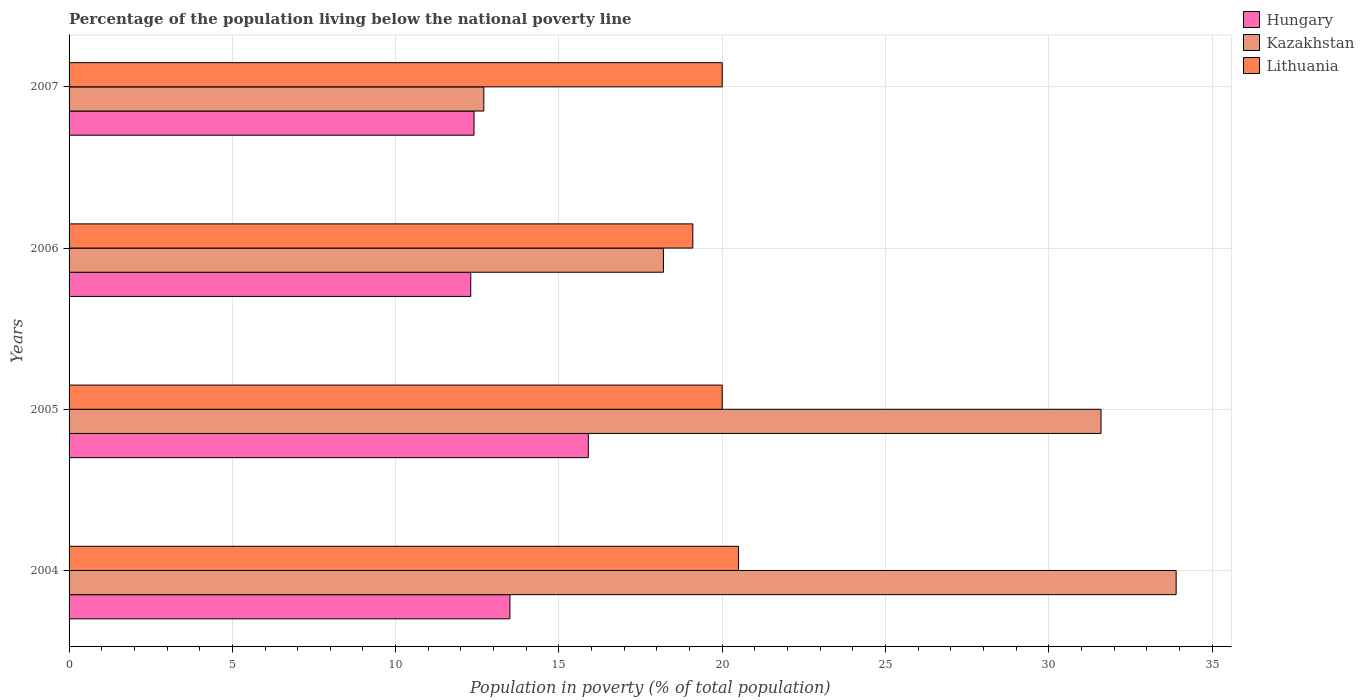How many bars are there on the 2nd tick from the top?
Offer a very short reply. 3. How many bars are there on the 1st tick from the bottom?
Give a very brief answer. 3. What is the label of the 1st group of bars from the top?
Your answer should be compact. 2007. In how many cases, is the number of bars for a given year not equal to the number of legend labels?
Offer a terse response. 0. Across all years, what is the maximum percentage of the population living below the national poverty line in Kazakhstan?
Provide a short and direct response. 33.9. Across all years, what is the minimum percentage of the population living below the national poverty line in Kazakhstan?
Ensure brevity in your answer.  12.7. In which year was the percentage of the population living below the national poverty line in Hungary maximum?
Keep it short and to the point. 2005. What is the total percentage of the population living below the national poverty line in Lithuania in the graph?
Make the answer very short. 79.6. What is the difference between the percentage of the population living below the national poverty line in Kazakhstan in 2005 and that in 2007?
Provide a succinct answer. 18.9. What is the difference between the percentage of the population living below the national poverty line in Hungary in 2004 and the percentage of the population living below the national poverty line in Lithuania in 2007?
Make the answer very short. -6.5. What is the average percentage of the population living below the national poverty line in Hungary per year?
Make the answer very short. 13.53. In the year 2005, what is the difference between the percentage of the population living below the national poverty line in Kazakhstan and percentage of the population living below the national poverty line in Lithuania?
Offer a terse response. 11.6. What is the ratio of the percentage of the population living below the national poverty line in Kazakhstan in 2005 to that in 2006?
Provide a succinct answer. 1.74. Is the difference between the percentage of the population living below the national poverty line in Kazakhstan in 2005 and 2006 greater than the difference between the percentage of the population living below the national poverty line in Lithuania in 2005 and 2006?
Keep it short and to the point. Yes. What is the difference between the highest and the second highest percentage of the population living below the national poverty line in Kazakhstan?
Ensure brevity in your answer.  2.3. What is the difference between the highest and the lowest percentage of the population living below the national poverty line in Lithuania?
Keep it short and to the point. 1.4. What does the 1st bar from the top in 2005 represents?
Keep it short and to the point. Lithuania. What does the 2nd bar from the bottom in 2006 represents?
Keep it short and to the point. Kazakhstan. Is it the case that in every year, the sum of the percentage of the population living below the national poverty line in Hungary and percentage of the population living below the national poverty line in Lithuania is greater than the percentage of the population living below the national poverty line in Kazakhstan?
Offer a terse response. Yes. How many bars are there?
Make the answer very short. 12. Are all the bars in the graph horizontal?
Offer a very short reply. Yes. Are the values on the major ticks of X-axis written in scientific E-notation?
Provide a succinct answer. No. Does the graph contain any zero values?
Ensure brevity in your answer.  No. Does the graph contain grids?
Make the answer very short. Yes. Where does the legend appear in the graph?
Make the answer very short. Top right. What is the title of the graph?
Provide a succinct answer. Percentage of the population living below the national poverty line. What is the label or title of the X-axis?
Ensure brevity in your answer.  Population in poverty (% of total population). What is the Population in poverty (% of total population) in Hungary in 2004?
Offer a terse response. 13.5. What is the Population in poverty (% of total population) in Kazakhstan in 2004?
Keep it short and to the point. 33.9. What is the Population in poverty (% of total population) in Lithuania in 2004?
Your answer should be compact. 20.5. What is the Population in poverty (% of total population) in Hungary in 2005?
Keep it short and to the point. 15.9. What is the Population in poverty (% of total population) of Kazakhstan in 2005?
Your response must be concise. 31.6. What is the Population in poverty (% of total population) in Hungary in 2006?
Provide a succinct answer. 12.3. What is the Population in poverty (% of total population) of Kazakhstan in 2006?
Keep it short and to the point. 18.2. What is the Population in poverty (% of total population) of Lithuania in 2007?
Your answer should be compact. 20. Across all years, what is the maximum Population in poverty (% of total population) of Kazakhstan?
Offer a terse response. 33.9. Across all years, what is the maximum Population in poverty (% of total population) of Lithuania?
Your answer should be compact. 20.5. Across all years, what is the minimum Population in poverty (% of total population) in Hungary?
Ensure brevity in your answer.  12.3. What is the total Population in poverty (% of total population) in Hungary in the graph?
Keep it short and to the point. 54.1. What is the total Population in poverty (% of total population) in Kazakhstan in the graph?
Your response must be concise. 96.4. What is the total Population in poverty (% of total population) of Lithuania in the graph?
Make the answer very short. 79.6. What is the difference between the Population in poverty (% of total population) of Hungary in 2004 and that in 2006?
Offer a very short reply. 1.2. What is the difference between the Population in poverty (% of total population) of Kazakhstan in 2004 and that in 2006?
Your response must be concise. 15.7. What is the difference between the Population in poverty (% of total population) of Hungary in 2004 and that in 2007?
Keep it short and to the point. 1.1. What is the difference between the Population in poverty (% of total population) of Kazakhstan in 2004 and that in 2007?
Offer a very short reply. 21.2. What is the difference between the Population in poverty (% of total population) of Hungary in 2005 and that in 2006?
Keep it short and to the point. 3.6. What is the difference between the Population in poverty (% of total population) in Kazakhstan in 2005 and that in 2007?
Offer a very short reply. 18.9. What is the difference between the Population in poverty (% of total population) in Lithuania in 2005 and that in 2007?
Give a very brief answer. 0. What is the difference between the Population in poverty (% of total population) in Hungary in 2006 and that in 2007?
Offer a very short reply. -0.1. What is the difference between the Population in poverty (% of total population) in Kazakhstan in 2006 and that in 2007?
Provide a short and direct response. 5.5. What is the difference between the Population in poverty (% of total population) of Lithuania in 2006 and that in 2007?
Provide a succinct answer. -0.9. What is the difference between the Population in poverty (% of total population) in Hungary in 2004 and the Population in poverty (% of total population) in Kazakhstan in 2005?
Your response must be concise. -18.1. What is the difference between the Population in poverty (% of total population) of Hungary in 2004 and the Population in poverty (% of total population) of Lithuania in 2005?
Give a very brief answer. -6.5. What is the difference between the Population in poverty (% of total population) of Hungary in 2004 and the Population in poverty (% of total population) of Kazakhstan in 2006?
Provide a short and direct response. -4.7. What is the difference between the Population in poverty (% of total population) of Kazakhstan in 2004 and the Population in poverty (% of total population) of Lithuania in 2006?
Keep it short and to the point. 14.8. What is the difference between the Population in poverty (% of total population) in Hungary in 2005 and the Population in poverty (% of total population) in Kazakhstan in 2006?
Your answer should be compact. -2.3. What is the difference between the Population in poverty (% of total population) of Hungary in 2005 and the Population in poverty (% of total population) of Lithuania in 2006?
Your response must be concise. -3.2. What is the difference between the Population in poverty (% of total population) in Kazakhstan in 2005 and the Population in poverty (% of total population) in Lithuania in 2007?
Provide a succinct answer. 11.6. What is the difference between the Population in poverty (% of total population) in Hungary in 2006 and the Population in poverty (% of total population) in Lithuania in 2007?
Offer a very short reply. -7.7. What is the difference between the Population in poverty (% of total population) in Kazakhstan in 2006 and the Population in poverty (% of total population) in Lithuania in 2007?
Your response must be concise. -1.8. What is the average Population in poverty (% of total population) of Hungary per year?
Ensure brevity in your answer.  13.53. What is the average Population in poverty (% of total population) of Kazakhstan per year?
Your answer should be very brief. 24.1. What is the average Population in poverty (% of total population) in Lithuania per year?
Provide a succinct answer. 19.9. In the year 2004, what is the difference between the Population in poverty (% of total population) of Hungary and Population in poverty (% of total population) of Kazakhstan?
Provide a succinct answer. -20.4. In the year 2004, what is the difference between the Population in poverty (% of total population) of Hungary and Population in poverty (% of total population) of Lithuania?
Provide a succinct answer. -7. In the year 2004, what is the difference between the Population in poverty (% of total population) of Kazakhstan and Population in poverty (% of total population) of Lithuania?
Offer a terse response. 13.4. In the year 2005, what is the difference between the Population in poverty (% of total population) of Hungary and Population in poverty (% of total population) of Kazakhstan?
Your answer should be compact. -15.7. In the year 2005, what is the difference between the Population in poverty (% of total population) in Hungary and Population in poverty (% of total population) in Lithuania?
Provide a succinct answer. -4.1. In the year 2006, what is the difference between the Population in poverty (% of total population) of Kazakhstan and Population in poverty (% of total population) of Lithuania?
Give a very brief answer. -0.9. In the year 2007, what is the difference between the Population in poverty (% of total population) in Hungary and Population in poverty (% of total population) in Kazakhstan?
Make the answer very short. -0.3. In the year 2007, what is the difference between the Population in poverty (% of total population) of Hungary and Population in poverty (% of total population) of Lithuania?
Give a very brief answer. -7.6. In the year 2007, what is the difference between the Population in poverty (% of total population) of Kazakhstan and Population in poverty (% of total population) of Lithuania?
Your response must be concise. -7.3. What is the ratio of the Population in poverty (% of total population) of Hungary in 2004 to that in 2005?
Your response must be concise. 0.85. What is the ratio of the Population in poverty (% of total population) in Kazakhstan in 2004 to that in 2005?
Your answer should be compact. 1.07. What is the ratio of the Population in poverty (% of total population) of Lithuania in 2004 to that in 2005?
Give a very brief answer. 1.02. What is the ratio of the Population in poverty (% of total population) in Hungary in 2004 to that in 2006?
Provide a succinct answer. 1.1. What is the ratio of the Population in poverty (% of total population) of Kazakhstan in 2004 to that in 2006?
Your answer should be very brief. 1.86. What is the ratio of the Population in poverty (% of total population) of Lithuania in 2004 to that in 2006?
Your response must be concise. 1.07. What is the ratio of the Population in poverty (% of total population) in Hungary in 2004 to that in 2007?
Keep it short and to the point. 1.09. What is the ratio of the Population in poverty (% of total population) in Kazakhstan in 2004 to that in 2007?
Offer a terse response. 2.67. What is the ratio of the Population in poverty (% of total population) in Lithuania in 2004 to that in 2007?
Keep it short and to the point. 1.02. What is the ratio of the Population in poverty (% of total population) in Hungary in 2005 to that in 2006?
Your response must be concise. 1.29. What is the ratio of the Population in poverty (% of total population) of Kazakhstan in 2005 to that in 2006?
Your response must be concise. 1.74. What is the ratio of the Population in poverty (% of total population) of Lithuania in 2005 to that in 2006?
Offer a terse response. 1.05. What is the ratio of the Population in poverty (% of total population) of Hungary in 2005 to that in 2007?
Provide a short and direct response. 1.28. What is the ratio of the Population in poverty (% of total population) in Kazakhstan in 2005 to that in 2007?
Your answer should be compact. 2.49. What is the ratio of the Population in poverty (% of total population) in Lithuania in 2005 to that in 2007?
Keep it short and to the point. 1. What is the ratio of the Population in poverty (% of total population) of Kazakhstan in 2006 to that in 2007?
Ensure brevity in your answer.  1.43. What is the ratio of the Population in poverty (% of total population) of Lithuania in 2006 to that in 2007?
Provide a short and direct response. 0.95. What is the difference between the highest and the second highest Population in poverty (% of total population) of Kazakhstan?
Ensure brevity in your answer.  2.3. What is the difference between the highest and the second highest Population in poverty (% of total population) in Lithuania?
Your response must be concise. 0.5. What is the difference between the highest and the lowest Population in poverty (% of total population) of Kazakhstan?
Make the answer very short. 21.2. 